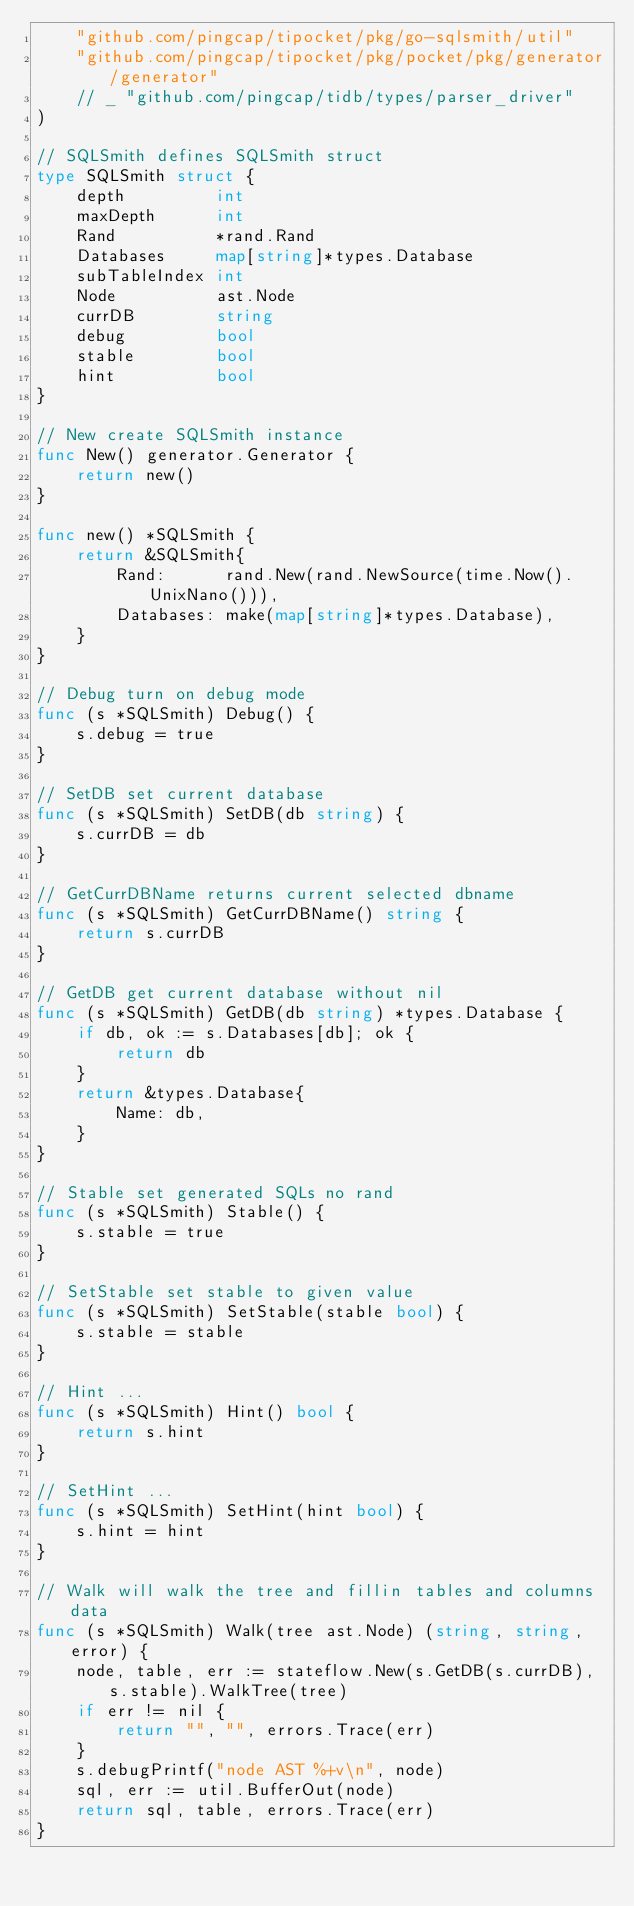Convert code to text. <code><loc_0><loc_0><loc_500><loc_500><_Go_>	"github.com/pingcap/tipocket/pkg/go-sqlsmith/util"
	"github.com/pingcap/tipocket/pkg/pocket/pkg/generator/generator"
	// _ "github.com/pingcap/tidb/types/parser_driver"
)

// SQLSmith defines SQLSmith struct
type SQLSmith struct {
	depth         int
	maxDepth      int
	Rand          *rand.Rand
	Databases     map[string]*types.Database
	subTableIndex int
	Node          ast.Node
	currDB        string
	debug         bool
	stable        bool
	hint          bool
}

// New create SQLSmith instance
func New() generator.Generator {
	return new()
}

func new() *SQLSmith {
	return &SQLSmith{
		Rand:      rand.New(rand.NewSource(time.Now().UnixNano())),
		Databases: make(map[string]*types.Database),
	}
}

// Debug turn on debug mode
func (s *SQLSmith) Debug() {
	s.debug = true
}

// SetDB set current database
func (s *SQLSmith) SetDB(db string) {
	s.currDB = db
}

// GetCurrDBName returns current selected dbname
func (s *SQLSmith) GetCurrDBName() string {
	return s.currDB
}

// GetDB get current database without nil
func (s *SQLSmith) GetDB(db string) *types.Database {
	if db, ok := s.Databases[db]; ok {
		return db
	}
	return &types.Database{
		Name: db,
	}
}

// Stable set generated SQLs no rand
func (s *SQLSmith) Stable() {
	s.stable = true
}

// SetStable set stable to given value
func (s *SQLSmith) SetStable(stable bool) {
	s.stable = stable
}

// Hint ...
func (s *SQLSmith) Hint() bool {
	return s.hint
}

// SetHint ...
func (s *SQLSmith) SetHint(hint bool) {
	s.hint = hint
}

// Walk will walk the tree and fillin tables and columns data
func (s *SQLSmith) Walk(tree ast.Node) (string, string, error) {
	node, table, err := stateflow.New(s.GetDB(s.currDB), s.stable).WalkTree(tree)
	if err != nil {
		return "", "", errors.Trace(err)
	}
	s.debugPrintf("node AST %+v\n", node)
	sql, err := util.BufferOut(node)
	return sql, table, errors.Trace(err)
}
</code> 